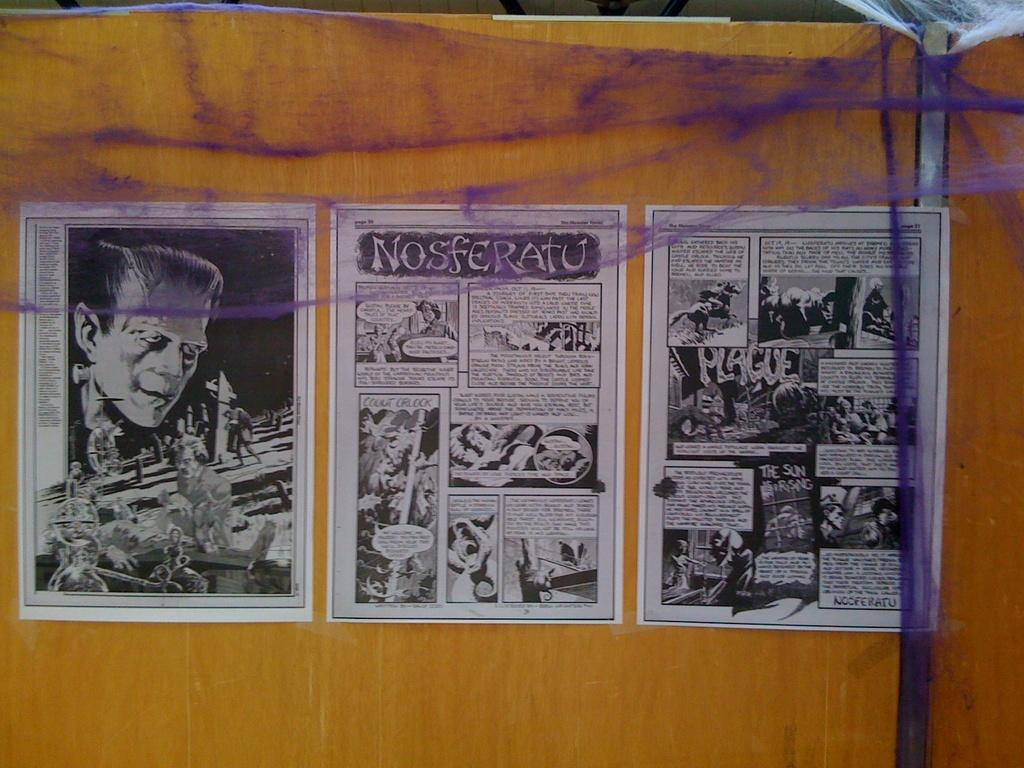<image>
Present a compact description of the photo's key features. Three pages from the Nosferatu comic against the wall. 